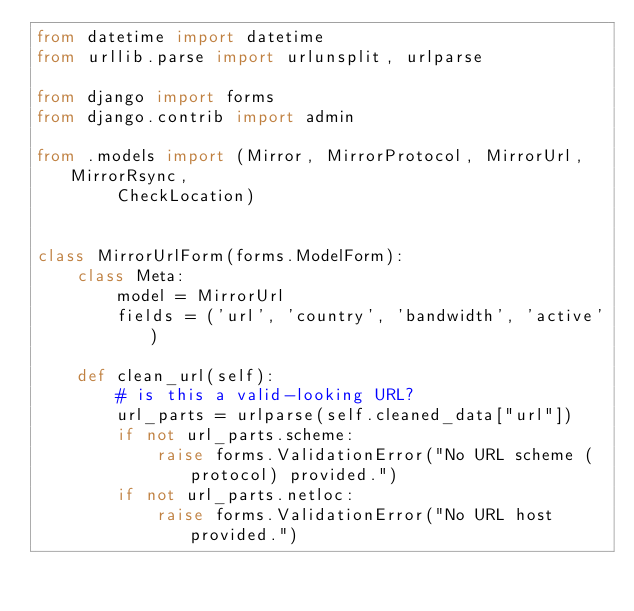<code> <loc_0><loc_0><loc_500><loc_500><_Python_>from datetime import datetime
from urllib.parse import urlunsplit, urlparse

from django import forms
from django.contrib import admin

from .models import (Mirror, MirrorProtocol, MirrorUrl, MirrorRsync,
        CheckLocation)


class MirrorUrlForm(forms.ModelForm):
    class Meta:
        model = MirrorUrl
        fields = ('url', 'country', 'bandwidth', 'active')

    def clean_url(self):
        # is this a valid-looking URL?
        url_parts = urlparse(self.cleaned_data["url"])
        if not url_parts.scheme:
            raise forms.ValidationError("No URL scheme (protocol) provided.")
        if not url_parts.netloc:
            raise forms.ValidationError("No URL host provided.")</code> 